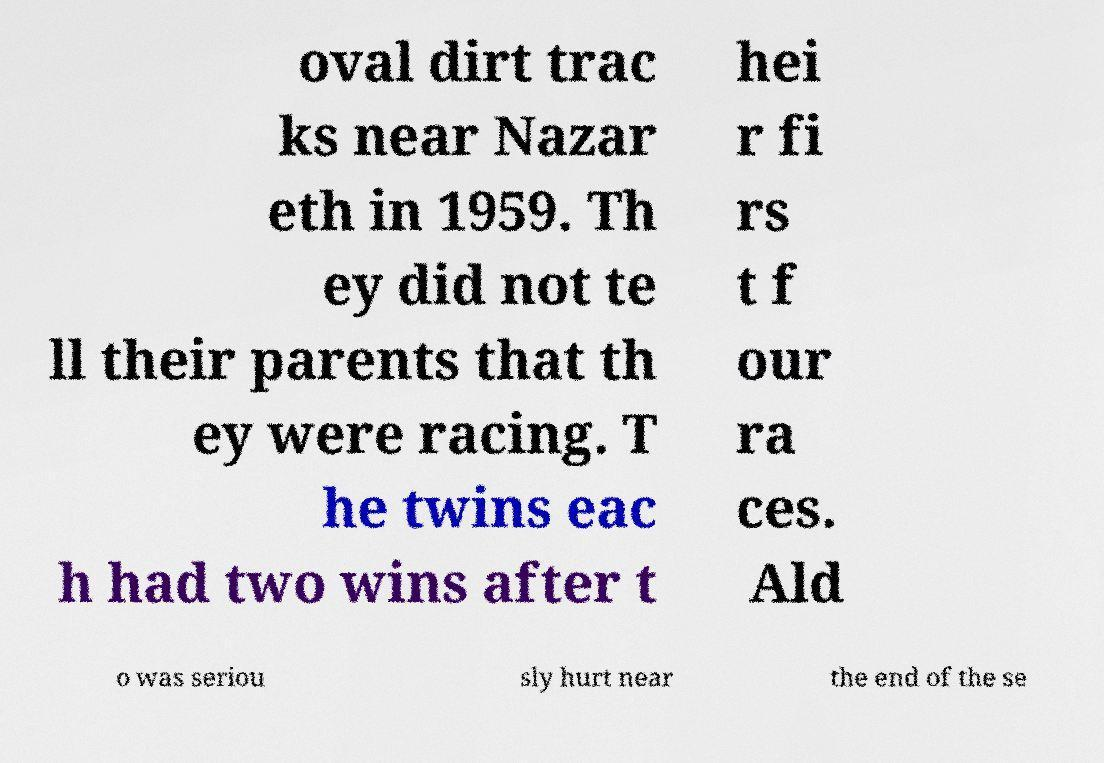Can you accurately transcribe the text from the provided image for me? oval dirt trac ks near Nazar eth in 1959. Th ey did not te ll their parents that th ey were racing. T he twins eac h had two wins after t hei r fi rs t f our ra ces. Ald o was seriou sly hurt near the end of the se 